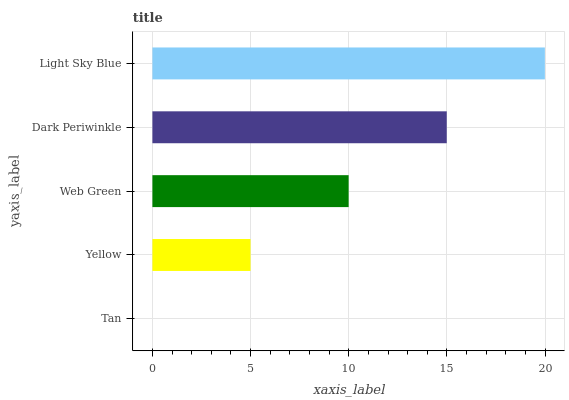Is Tan the minimum?
Answer yes or no. Yes. Is Light Sky Blue the maximum?
Answer yes or no. Yes. Is Yellow the minimum?
Answer yes or no. No. Is Yellow the maximum?
Answer yes or no. No. Is Yellow greater than Tan?
Answer yes or no. Yes. Is Tan less than Yellow?
Answer yes or no. Yes. Is Tan greater than Yellow?
Answer yes or no. No. Is Yellow less than Tan?
Answer yes or no. No. Is Web Green the high median?
Answer yes or no. Yes. Is Web Green the low median?
Answer yes or no. Yes. Is Yellow the high median?
Answer yes or no. No. Is Dark Periwinkle the low median?
Answer yes or no. No. 